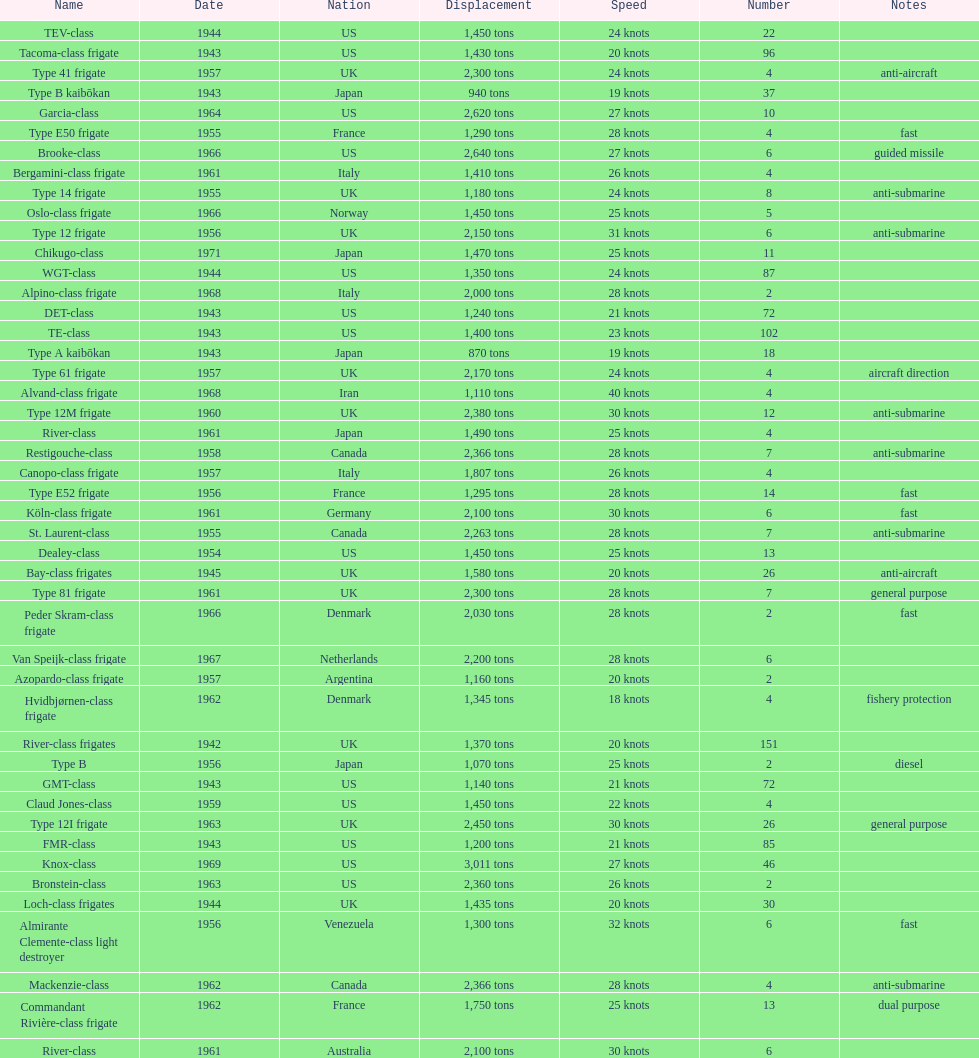How many tons of displacement does type b have? 940 tons. 